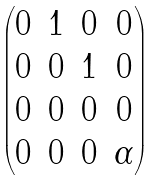Convert formula to latex. <formula><loc_0><loc_0><loc_500><loc_500>\begin{pmatrix} 0 & 1 & 0 & 0 \\ 0 & 0 & 1 & 0 \\ 0 & 0 & 0 & 0 \\ 0 & 0 & 0 & \alpha \end{pmatrix}</formula> 